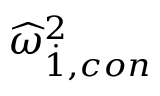<formula> <loc_0><loc_0><loc_500><loc_500>{ \widehat { \omega } } _ { \dot { 1 } , c o n } ^ { 2 }</formula> 